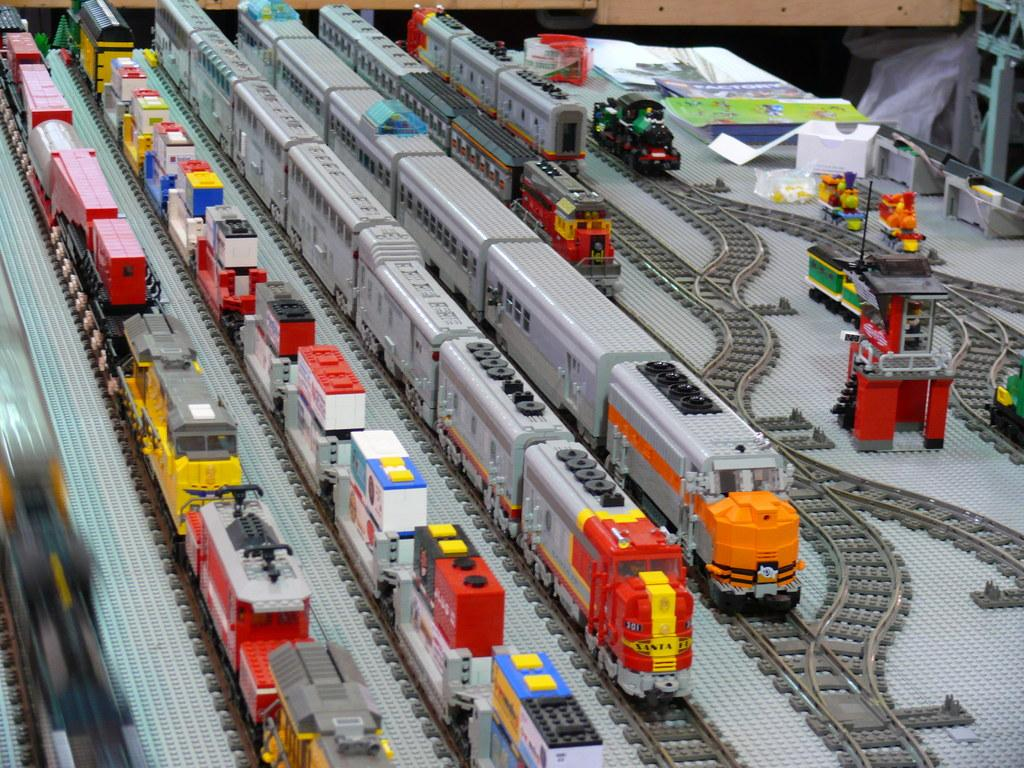What type of objects can be seen in the image? There are toys and trains in the image. What is associated with the trains in the image? There are train tracks in the image. Are there any other objects present in the image besides the toys and trains? Yes, there are other objects in the image. How many babies are crawling on the train tracks in the image? There are no babies present in the image, and therefore no babies can be seen crawling on the train tracks. 